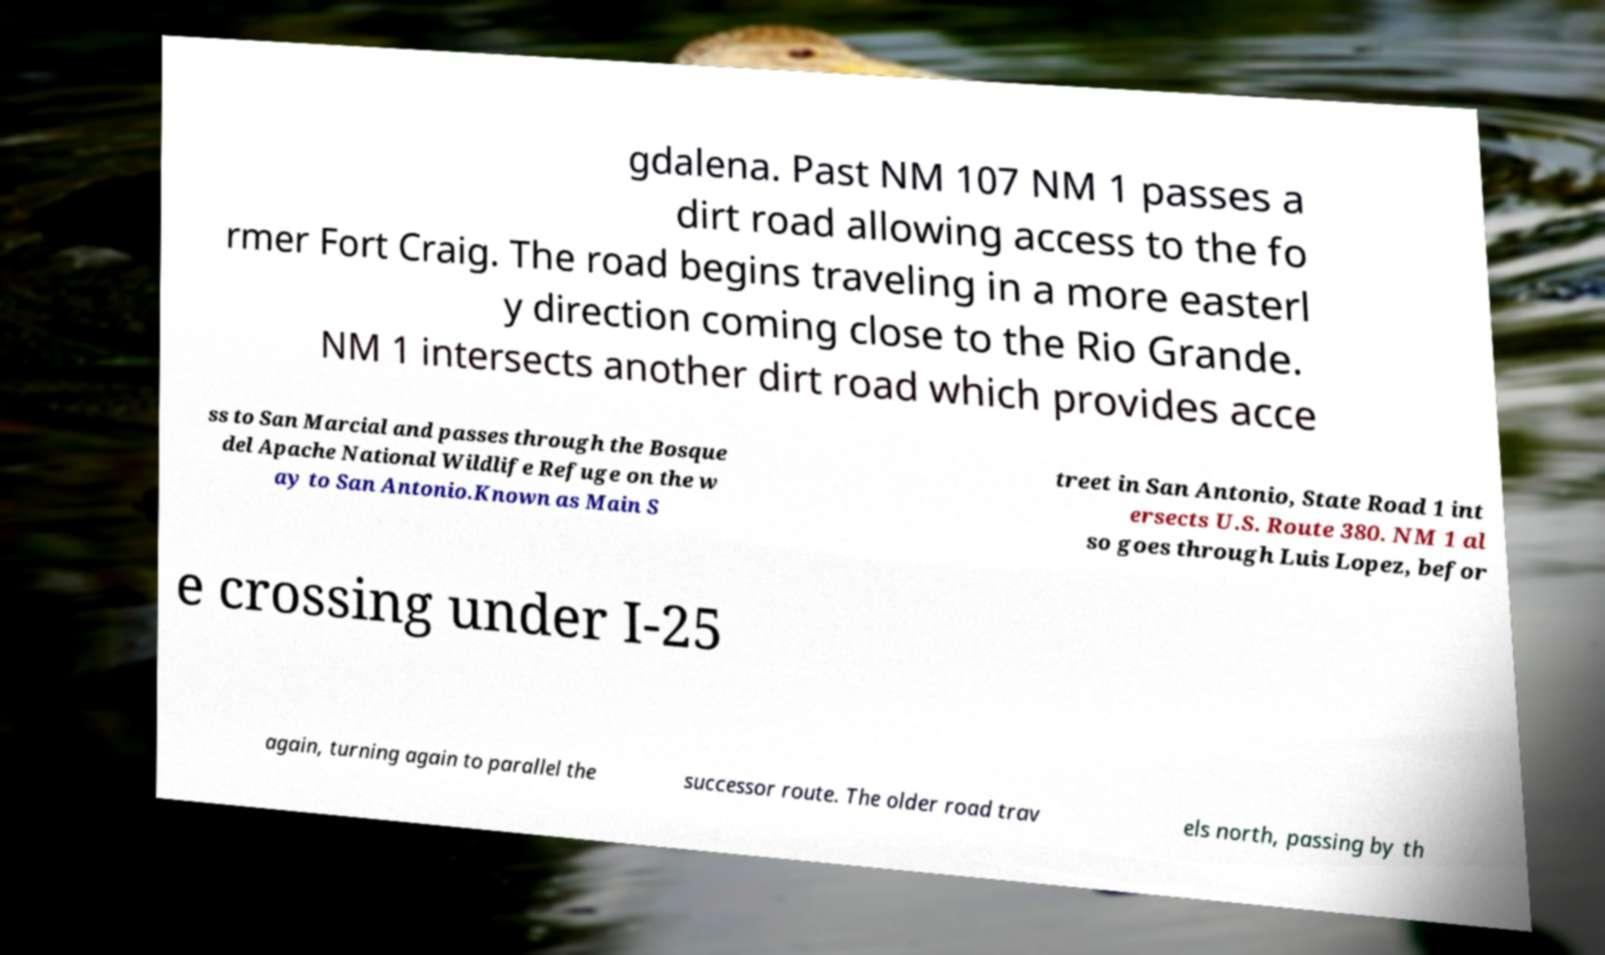Could you extract and type out the text from this image? gdalena. Past NM 107 NM 1 passes a dirt road allowing access to the fo rmer Fort Craig. The road begins traveling in a more easterl y direction coming close to the Rio Grande. NM 1 intersects another dirt road which provides acce ss to San Marcial and passes through the Bosque del Apache National Wildlife Refuge on the w ay to San Antonio.Known as Main S treet in San Antonio, State Road 1 int ersects U.S. Route 380. NM 1 al so goes through Luis Lopez, befor e crossing under I-25 again, turning again to parallel the successor route. The older road trav els north, passing by th 